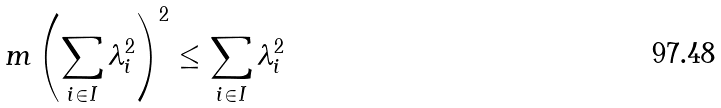<formula> <loc_0><loc_0><loc_500><loc_500>m \left ( \sum _ { i \in I } \lambda _ { i } ^ { 2 } \right ) ^ { 2 } \leq \sum _ { i \in I } \lambda _ { i } ^ { 2 }</formula> 